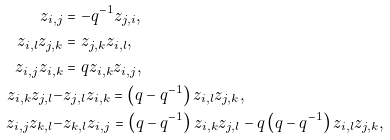<formula> <loc_0><loc_0><loc_500><loc_500>z _ { i , j } & = - q ^ { - 1 } z _ { j , i } , \\ z _ { i , l } z _ { j , k } & = z _ { j , k } z _ { i , l } , \\ z _ { i , j } z _ { i , k } & = q z _ { i , k } z _ { i , j } , \\ z _ { i , k } z _ { j , l } - & z _ { j , l } z _ { i , k } = \left ( q - q ^ { - 1 } \right ) z _ { i , l } z _ { j , k } , \\ z _ { i , j } z _ { k , l } - & z _ { k , l } z _ { i , j } = \left ( q - q ^ { - 1 } \right ) z _ { i , k } z _ { j , l } - q \left ( q - q ^ { - 1 } \right ) z _ { i , l } z _ { j , k } ,</formula> 